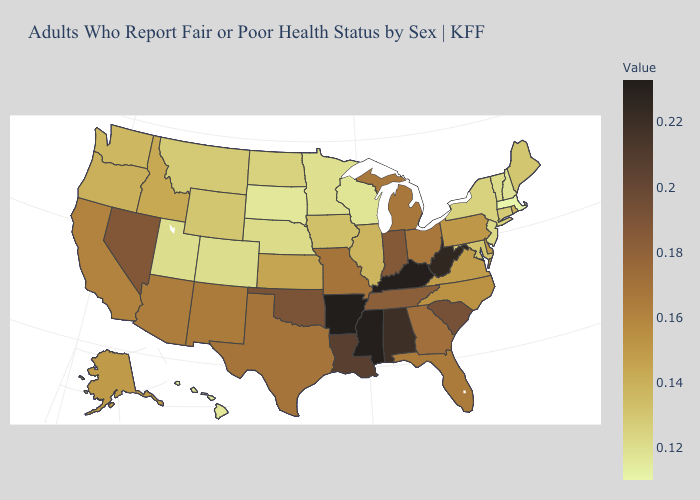Among the states that border Alabama , does Mississippi have the highest value?
Give a very brief answer. Yes. Does Mississippi have the highest value in the USA?
Short answer required. No. Does Pennsylvania have the highest value in the Northeast?
Short answer required. Yes. Does Missouri have the highest value in the USA?
Write a very short answer. No. Which states have the highest value in the USA?
Quick response, please. Arkansas. Which states have the lowest value in the West?
Be succinct. Hawaii. Which states have the lowest value in the USA?
Keep it brief. Massachusetts. Does Missouri have the highest value in the MidWest?
Give a very brief answer. No. 